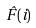<formula> <loc_0><loc_0><loc_500><loc_500>\hat { F } ( i )</formula> 